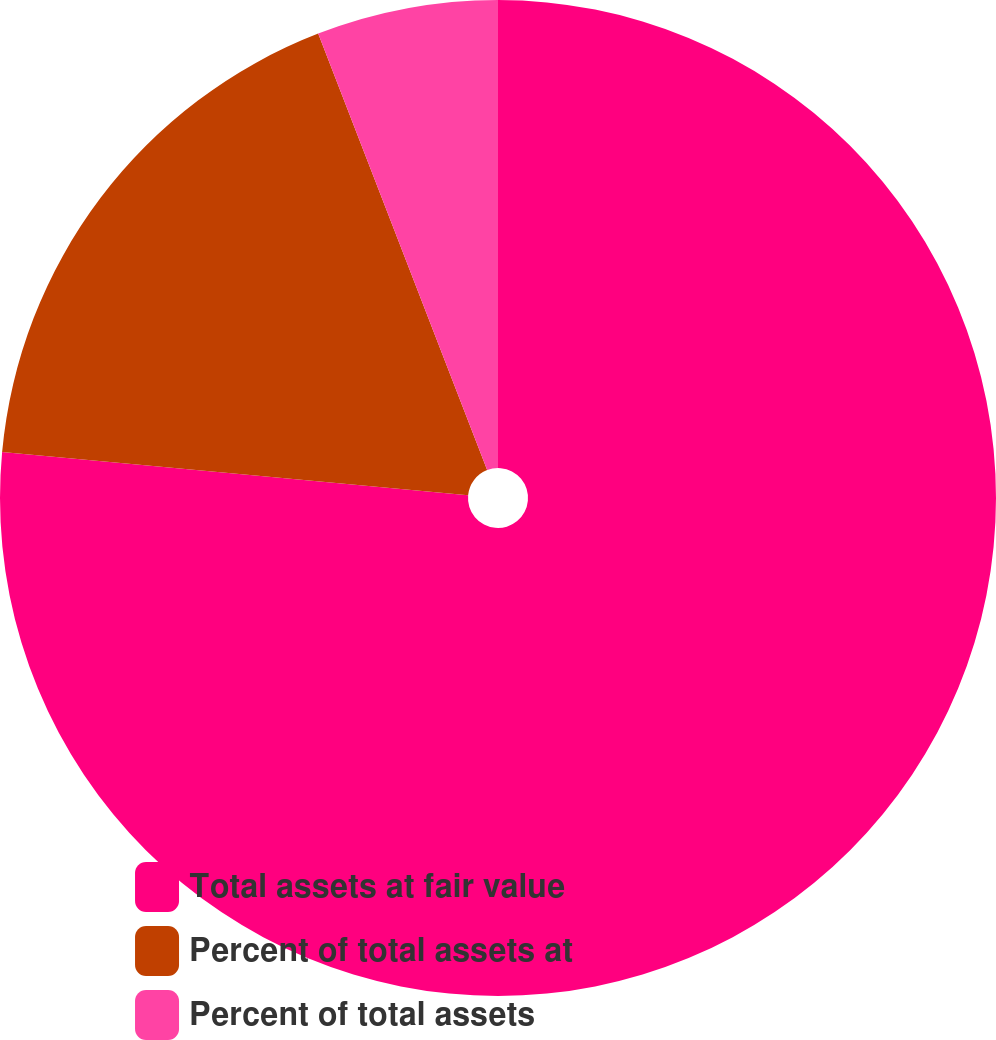Convert chart to OTSL. <chart><loc_0><loc_0><loc_500><loc_500><pie_chart><fcel>Total assets at fair value<fcel>Percent of total assets at<fcel>Percent of total assets<nl><fcel>76.47%<fcel>17.65%<fcel>5.88%<nl></chart> 